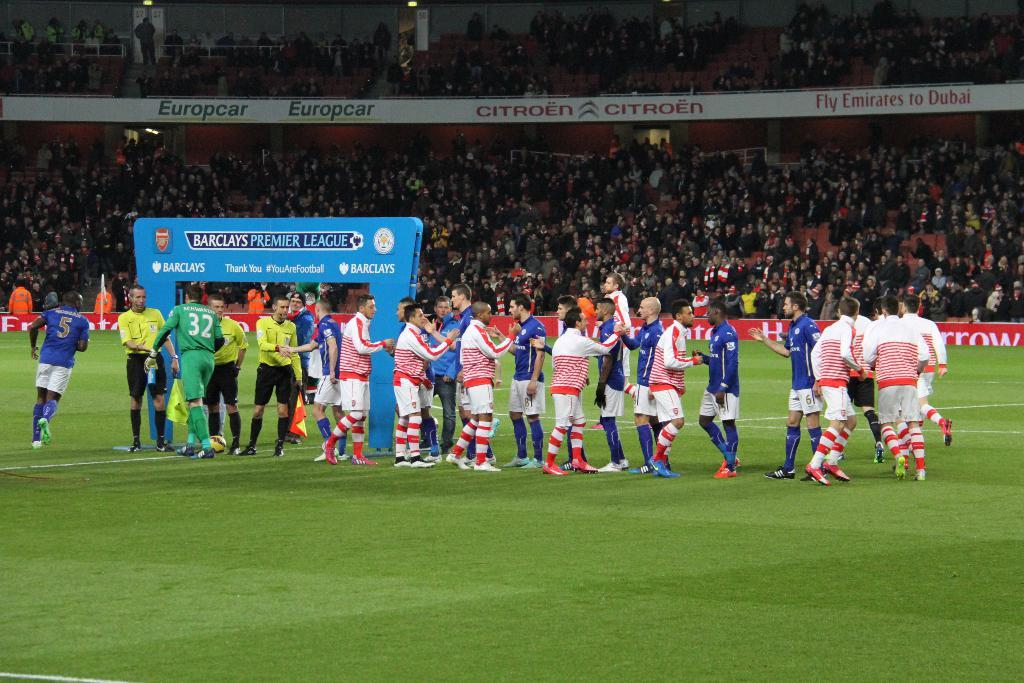<image>
Describe the image concisely. Premier League players from different teams shake hands and high five each other. 